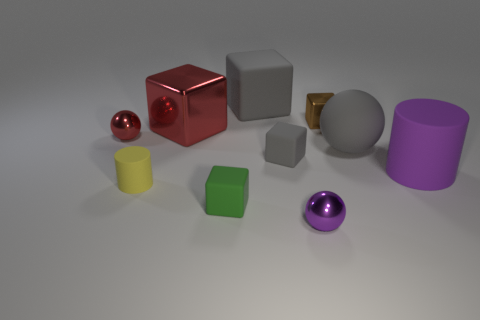Subtract all small metal balls. How many balls are left? 1 Subtract all red cylinders. How many gray cubes are left? 2 Subtract 1 balls. How many balls are left? 2 Subtract all green cubes. How many cubes are left? 4 Subtract all spheres. How many objects are left? 7 Subtract all green blocks. Subtract all blue spheres. How many blocks are left? 4 Subtract all tiny metal objects. Subtract all large purple matte objects. How many objects are left? 6 Add 5 large gray balls. How many large gray balls are left? 6 Add 5 tiny rubber blocks. How many tiny rubber blocks exist? 7 Subtract 0 cyan blocks. How many objects are left? 10 